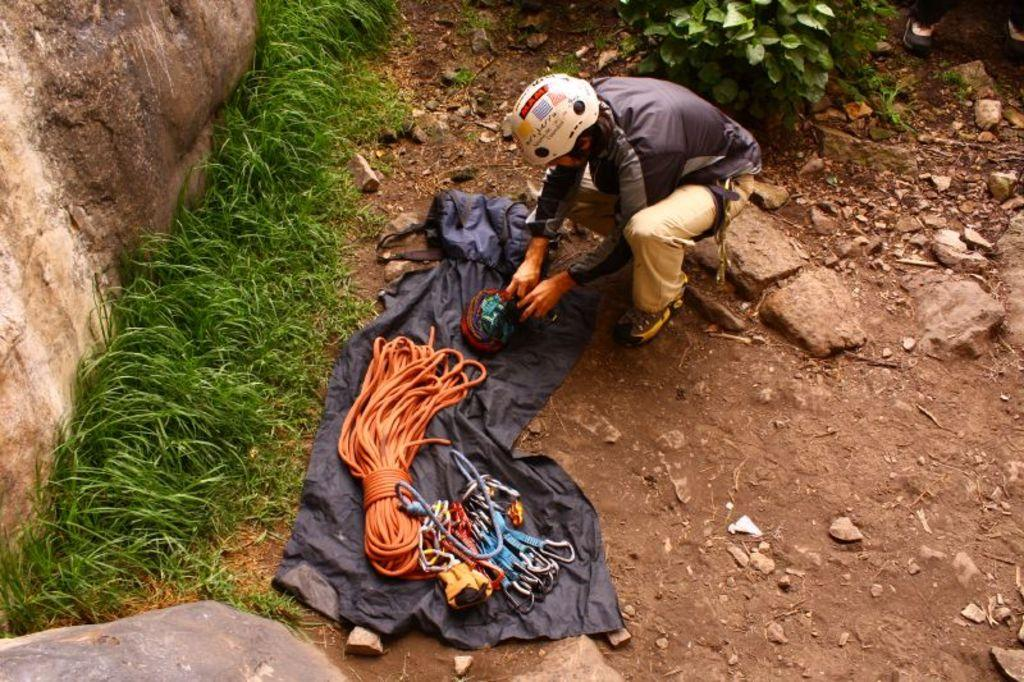What is the main subject in the center of the image? There is a person in the center of the image. What other objects are present in the center of the image? There is cloth and a rope in the center of the image, along with some objects. What can be seen on the right side of the image? There are stones and a tree on the right side of the image. What is present on the left side of the image? There are rocks and grass on the left side of the image. Is there a volcano visible in the image? No, there is no volcano present in the image. What type of camp can be seen in the image? There is no camp present in the image. 